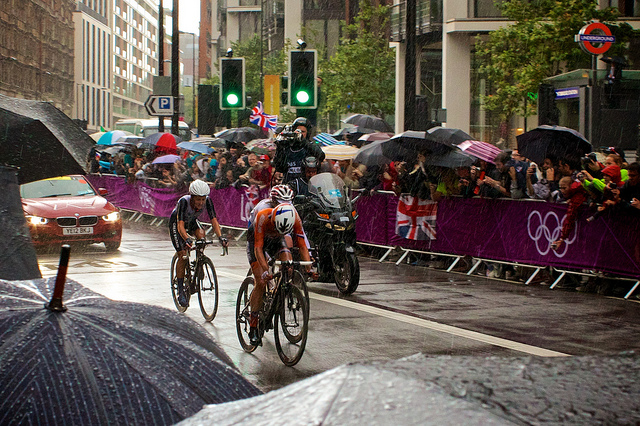Please transcribe the text in this image. P 